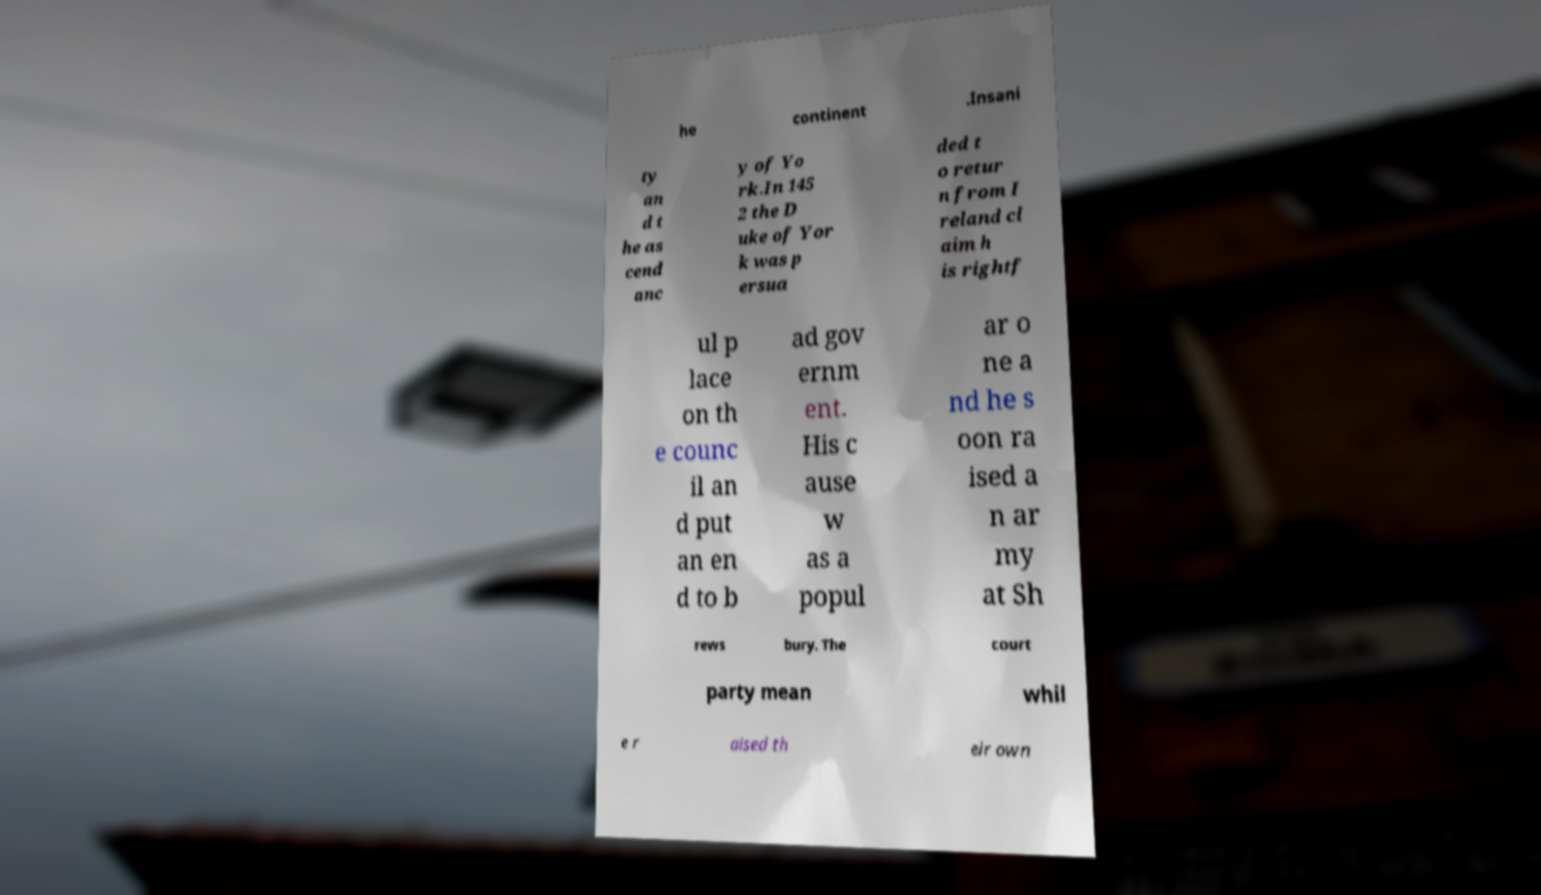What messages or text are displayed in this image? I need them in a readable, typed format. he continent .Insani ty an d t he as cend anc y of Yo rk.In 145 2 the D uke of Yor k was p ersua ded t o retur n from I reland cl aim h is rightf ul p lace on th e counc il an d put an en d to b ad gov ernm ent. His c ause w as a popul ar o ne a nd he s oon ra ised a n ar my at Sh rews bury. The court party mean whil e r aised th eir own 